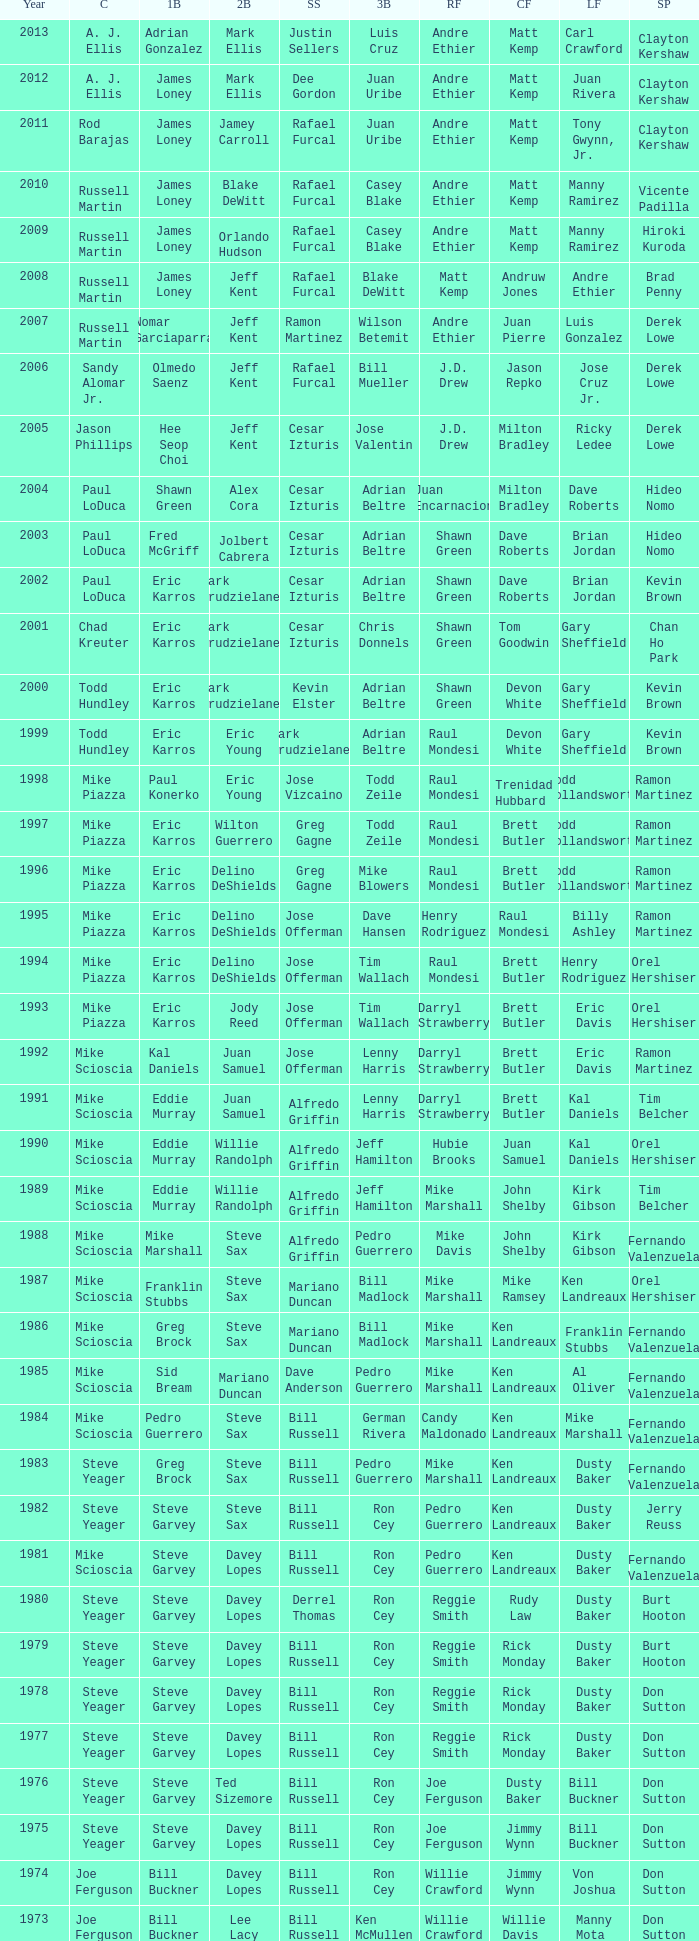Who was the RF when the SP was vicente padilla? Andre Ethier. 